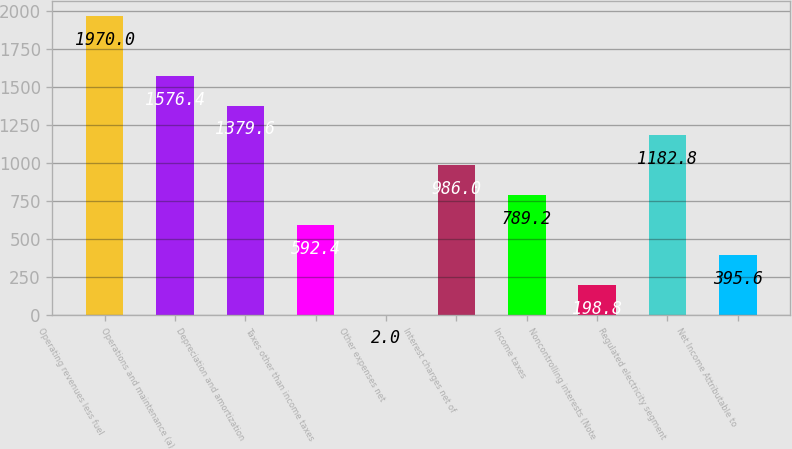Convert chart to OTSL. <chart><loc_0><loc_0><loc_500><loc_500><bar_chart><fcel>Operating revenues less fuel<fcel>Operations and maintenance (a)<fcel>Depreciation and amortization<fcel>Taxes other than income taxes<fcel>Other expenses net<fcel>Interest charges net of<fcel>Income taxes<fcel>Noncontrolling interests (Note<fcel>Regulated electricity segment<fcel>Net Income Attributable to<nl><fcel>1970<fcel>1576.4<fcel>1379.6<fcel>592.4<fcel>2<fcel>986<fcel>789.2<fcel>198.8<fcel>1182.8<fcel>395.6<nl></chart> 